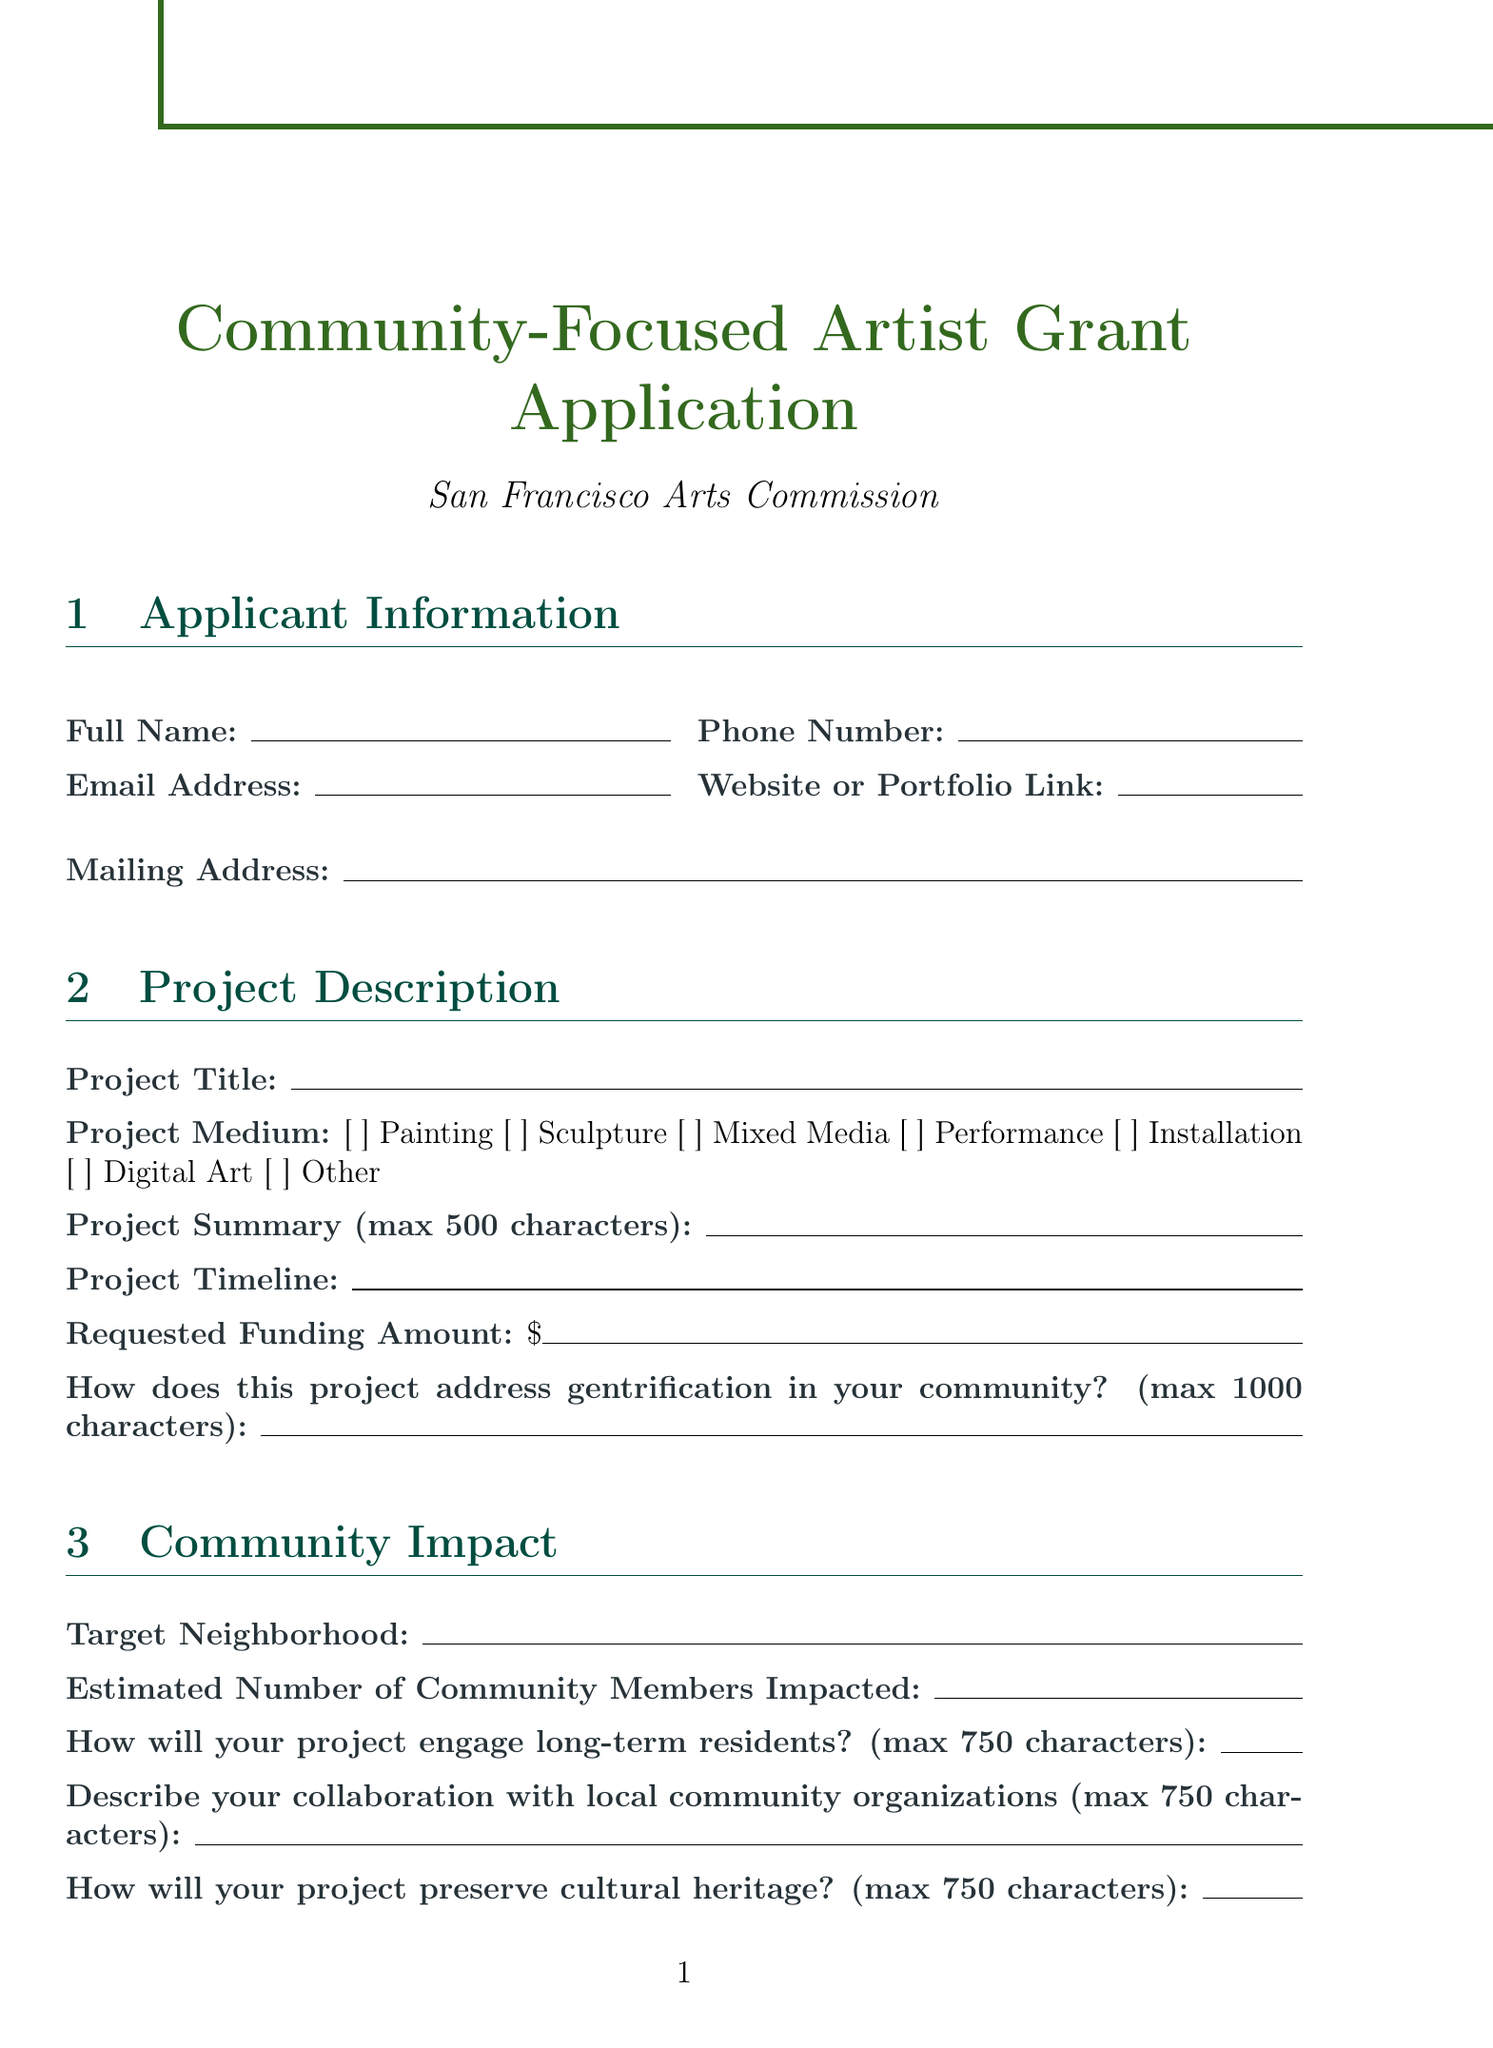What is the title of the form? The title of the form is provided at the top of the document.
Answer: Community-Focused Artist Grant Application Who is the organization behind the grant? The organization responsible for this grant application is mentioned below the title.
Answer: San Francisco Arts Commission What is the maximum character limit for the project summary? The character limit for the project summary is specified in the project description section.
Answer: 500 What is the estimated number of community members impacted? This number must be provided in the community impact section of the document.
Answer: Respondent-defined How will funds be used to combat displacement? This is a question within the budget section that requires a specific response related to fund allocation.
Answer: Respondent-defined What type of file is required for the detailed project budget? The document specifies the acceptable file formats for the budget in the budget section.
Answer: .pdf or .xlsx How does this project engage long-term residents? This question is found in the community impact section and requires a thoughtful response regarding community engagement.
Answer: Respondent-defined What is the deadline for submitting the application? The submission guidelines section presents the deadline for submissions.
Answer: 11:59 PM on September 30, 2023 What is one of the priorities for applications? The guidelines specify priorities for projects, which indicates what types of projects will be favored.
Answer: Addressing gentrification and preserving community identity 